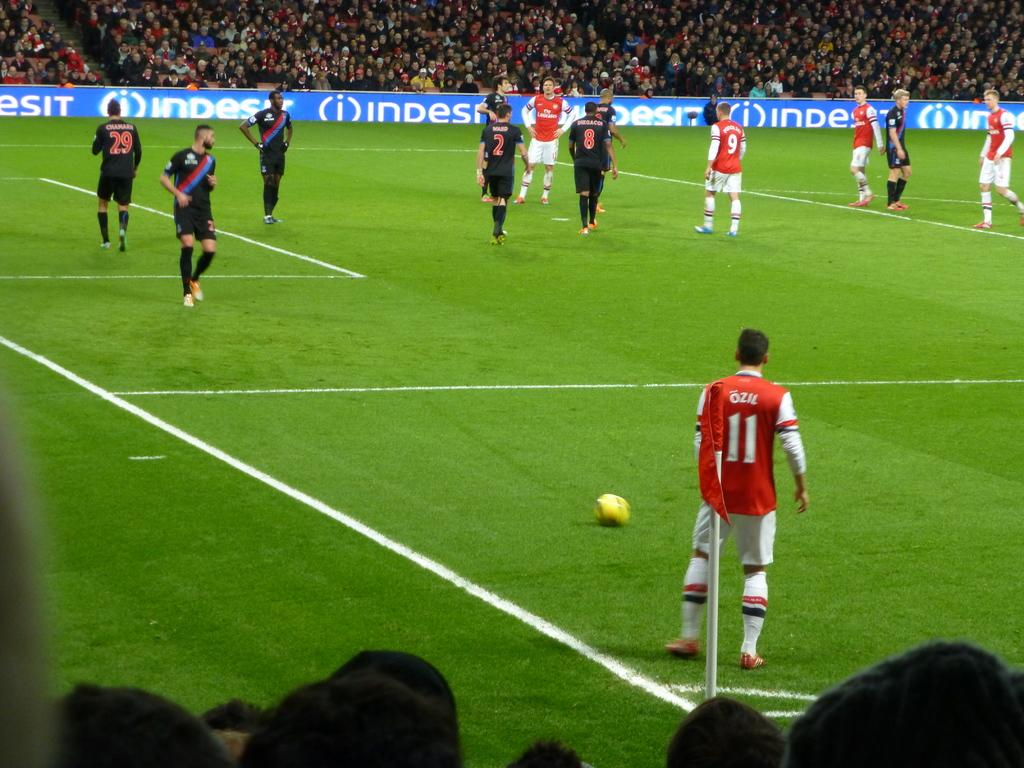<image>
Share a concise interpretation of the image provided. A man in a jersey with the number 11 approaching a ball 